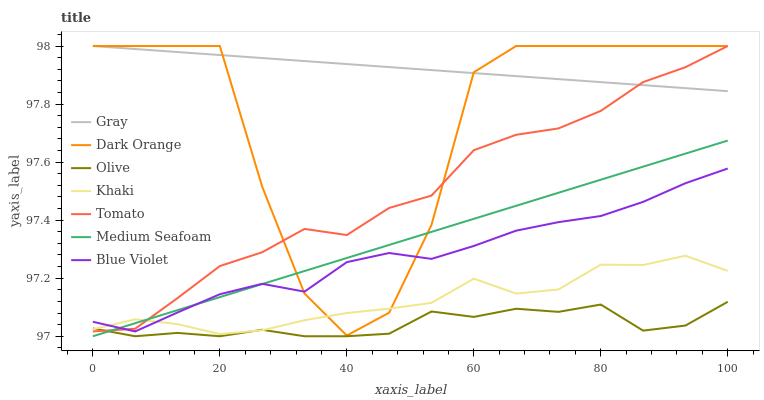Does Olive have the minimum area under the curve?
Answer yes or no. Yes. Does Gray have the maximum area under the curve?
Answer yes or no. Yes. Does Khaki have the minimum area under the curve?
Answer yes or no. No. Does Khaki have the maximum area under the curve?
Answer yes or no. No. Is Gray the smoothest?
Answer yes or no. Yes. Is Dark Orange the roughest?
Answer yes or no. Yes. Is Khaki the smoothest?
Answer yes or no. No. Is Khaki the roughest?
Answer yes or no. No. Does Olive have the lowest value?
Answer yes or no. Yes. Does Khaki have the lowest value?
Answer yes or no. No. Does Dark Orange have the highest value?
Answer yes or no. Yes. Does Khaki have the highest value?
Answer yes or no. No. Is Blue Violet less than Gray?
Answer yes or no. Yes. Is Gray greater than Olive?
Answer yes or no. Yes. Does Blue Violet intersect Tomato?
Answer yes or no. Yes. Is Blue Violet less than Tomato?
Answer yes or no. No. Is Blue Violet greater than Tomato?
Answer yes or no. No. Does Blue Violet intersect Gray?
Answer yes or no. No. 